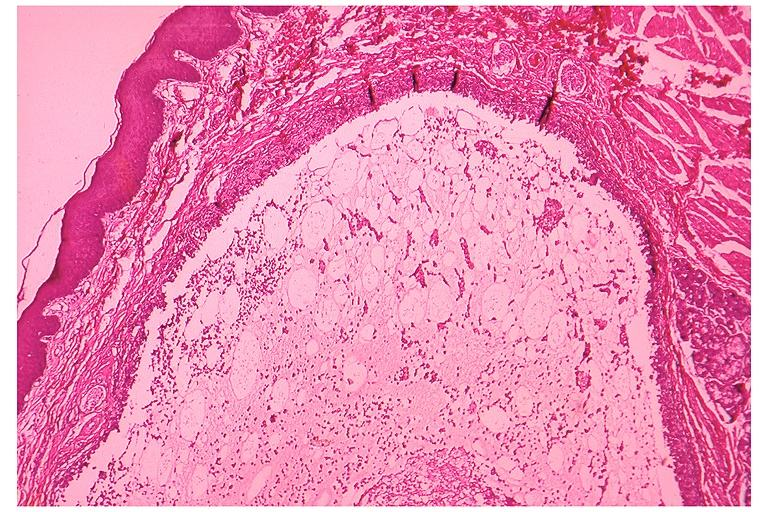where is this?
Answer the question using a single word or phrase. Oral 